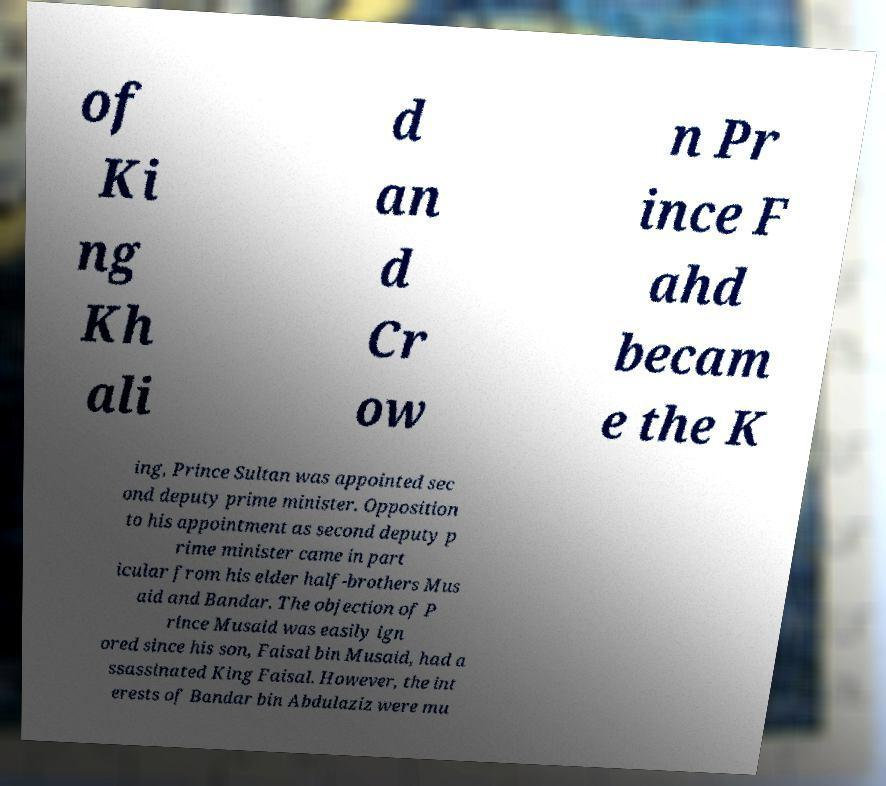Can you read and provide the text displayed in the image?This photo seems to have some interesting text. Can you extract and type it out for me? of Ki ng Kh ali d an d Cr ow n Pr ince F ahd becam e the K ing, Prince Sultan was appointed sec ond deputy prime minister. Opposition to his appointment as second deputy p rime minister came in part icular from his elder half-brothers Mus aid and Bandar. The objection of P rince Musaid was easily ign ored since his son, Faisal bin Musaid, had a ssassinated King Faisal. However, the int erests of Bandar bin Abdulaziz were mu 